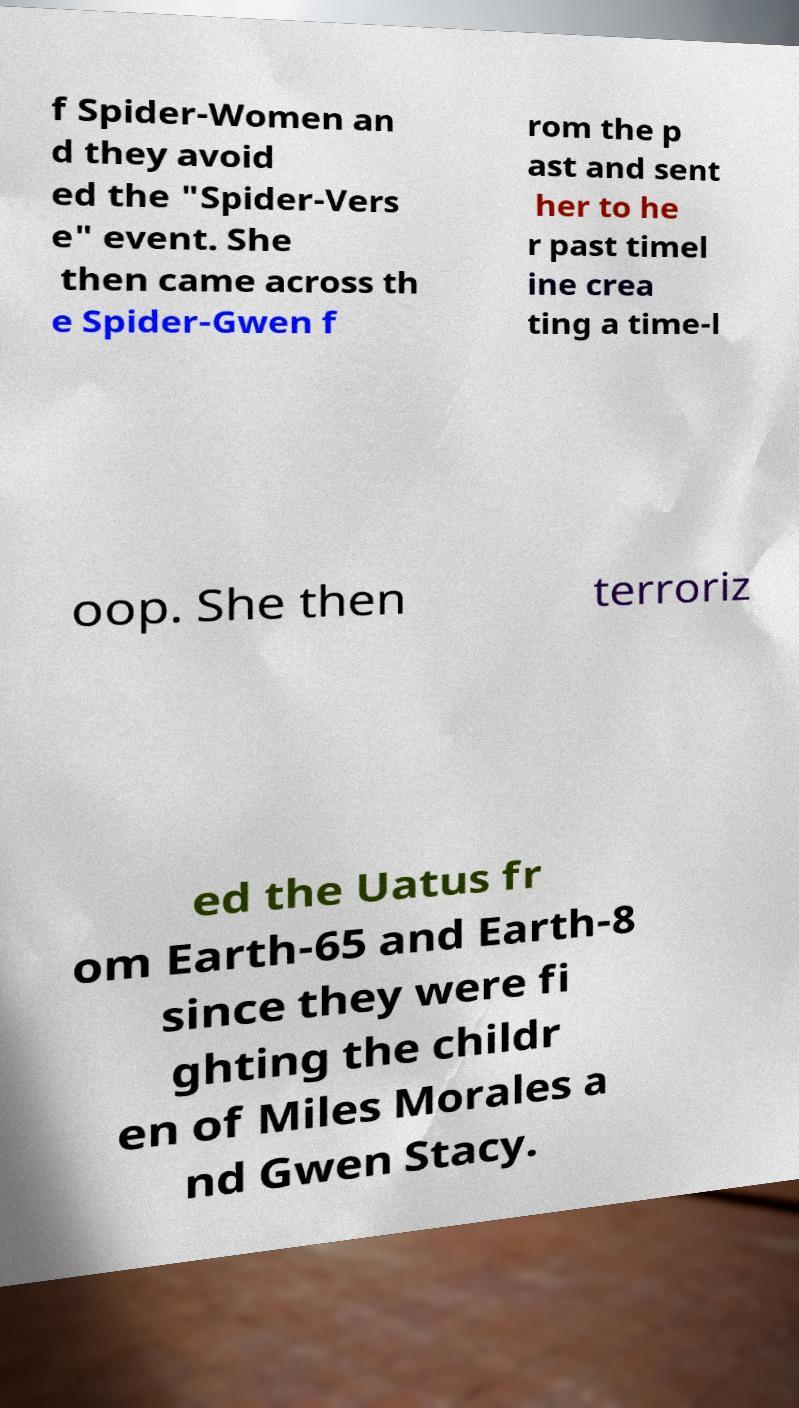I need the written content from this picture converted into text. Can you do that? f Spider-Women an d they avoid ed the "Spider-Vers e" event. She then came across th e Spider-Gwen f rom the p ast and sent her to he r past timel ine crea ting a time-l oop. She then terroriz ed the Uatus fr om Earth-65 and Earth-8 since they were fi ghting the childr en of Miles Morales a nd Gwen Stacy. 